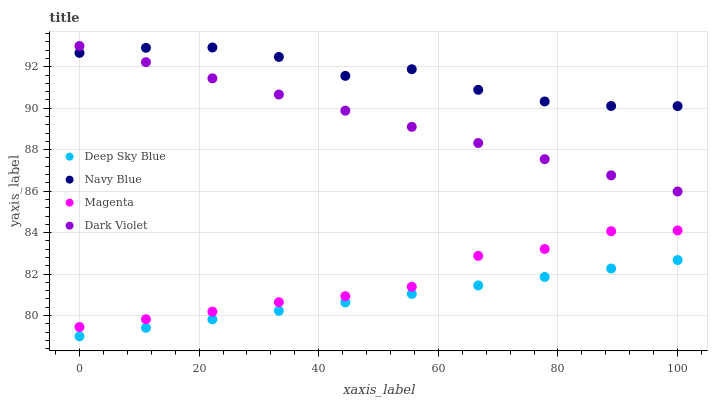Does Deep Sky Blue have the minimum area under the curve?
Answer yes or no. Yes. Does Navy Blue have the maximum area under the curve?
Answer yes or no. Yes. Does Magenta have the minimum area under the curve?
Answer yes or no. No. Does Magenta have the maximum area under the curve?
Answer yes or no. No. Is Deep Sky Blue the smoothest?
Answer yes or no. Yes. Is Navy Blue the roughest?
Answer yes or no. Yes. Is Magenta the smoothest?
Answer yes or no. No. Is Magenta the roughest?
Answer yes or no. No. Does Deep Sky Blue have the lowest value?
Answer yes or no. Yes. Does Magenta have the lowest value?
Answer yes or no. No. Does Dark Violet have the highest value?
Answer yes or no. Yes. Does Magenta have the highest value?
Answer yes or no. No. Is Deep Sky Blue less than Dark Violet?
Answer yes or no. Yes. Is Dark Violet greater than Magenta?
Answer yes or no. Yes. Does Dark Violet intersect Navy Blue?
Answer yes or no. Yes. Is Dark Violet less than Navy Blue?
Answer yes or no. No. Is Dark Violet greater than Navy Blue?
Answer yes or no. No. Does Deep Sky Blue intersect Dark Violet?
Answer yes or no. No. 